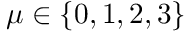Convert formula to latex. <formula><loc_0><loc_0><loc_500><loc_500>\mu \in \{ 0 , 1 , 2 , 3 \}</formula> 